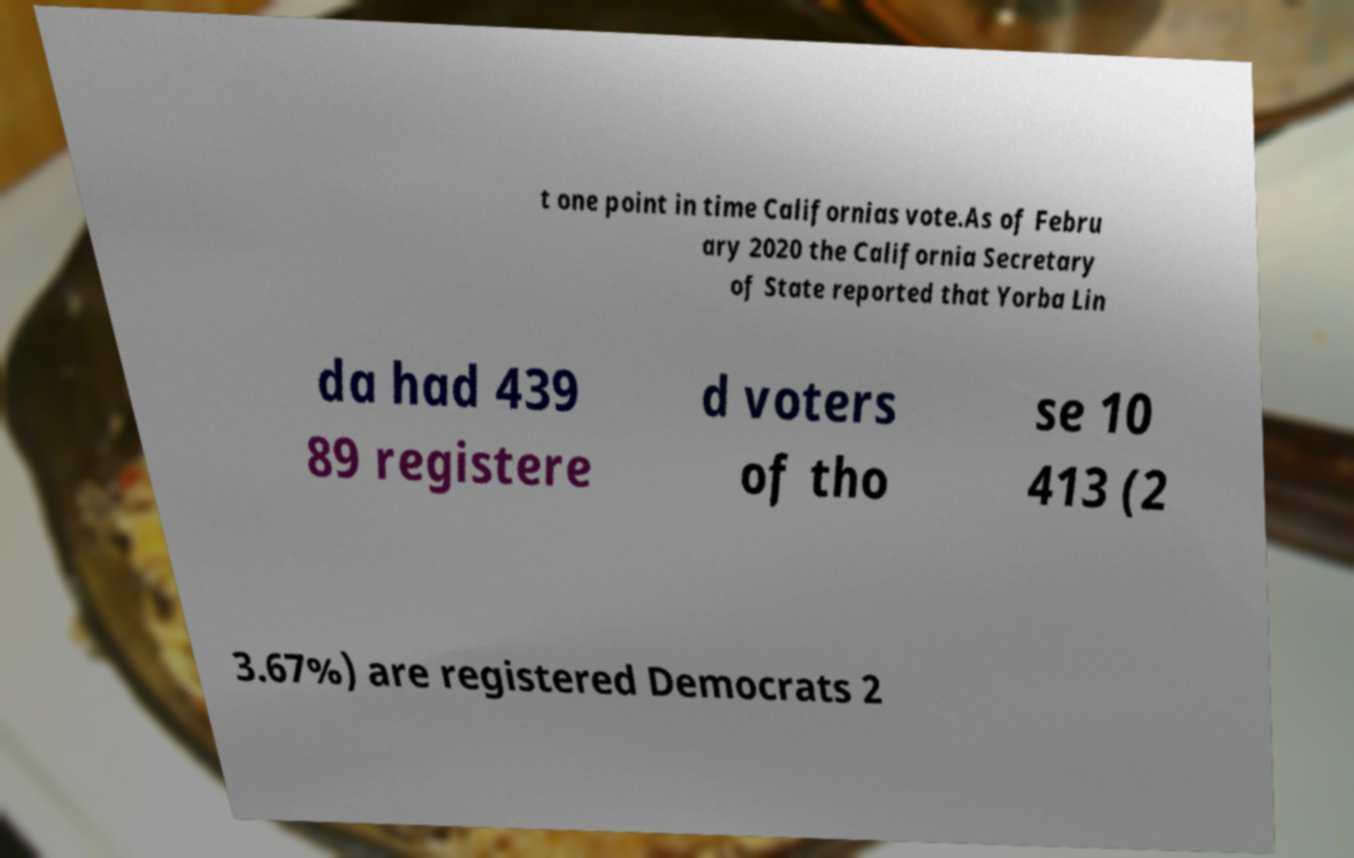Can you read and provide the text displayed in the image?This photo seems to have some interesting text. Can you extract and type it out for me? t one point in time Californias vote.As of Febru ary 2020 the California Secretary of State reported that Yorba Lin da had 439 89 registere d voters of tho se 10 413 (2 3.67%) are registered Democrats 2 